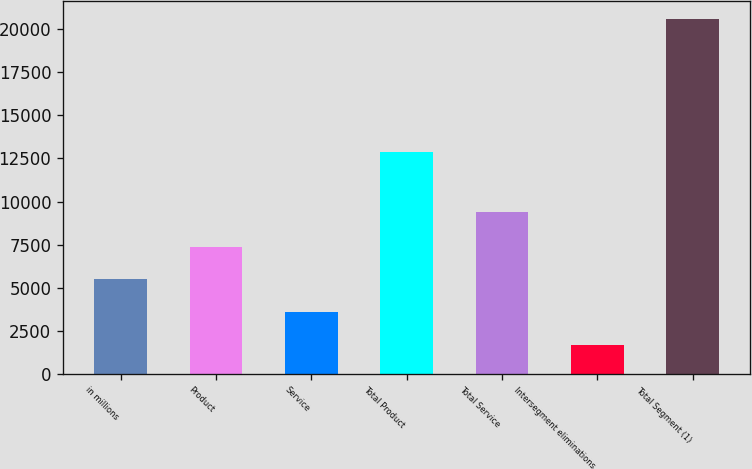Convert chart. <chart><loc_0><loc_0><loc_500><loc_500><bar_chart><fcel>in millions<fcel>Product<fcel>Service<fcel>Total Product<fcel>Total Service<fcel>Intersegment eliminations<fcel>Total Segment (1)<nl><fcel>5479.6<fcel>7370.4<fcel>3588.8<fcel>12896<fcel>9408<fcel>1698<fcel>20606<nl></chart> 